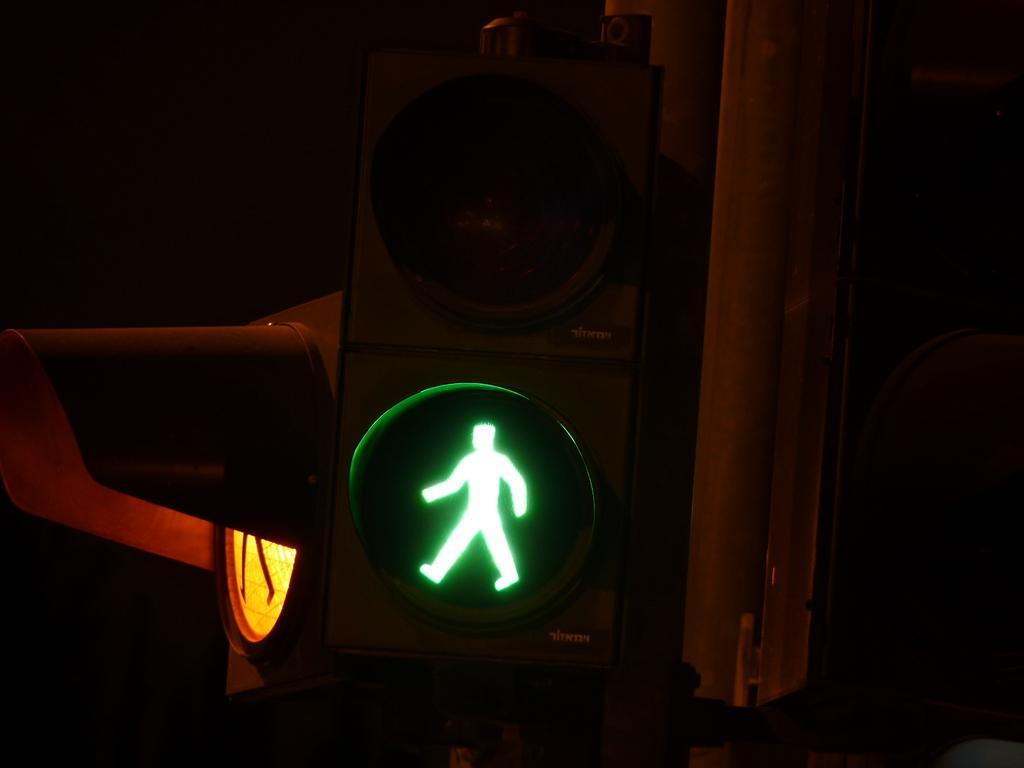Could you give a brief overview of what you see in this image? In this image, we can see traffic signals and pole. Background we can see the dark view. 